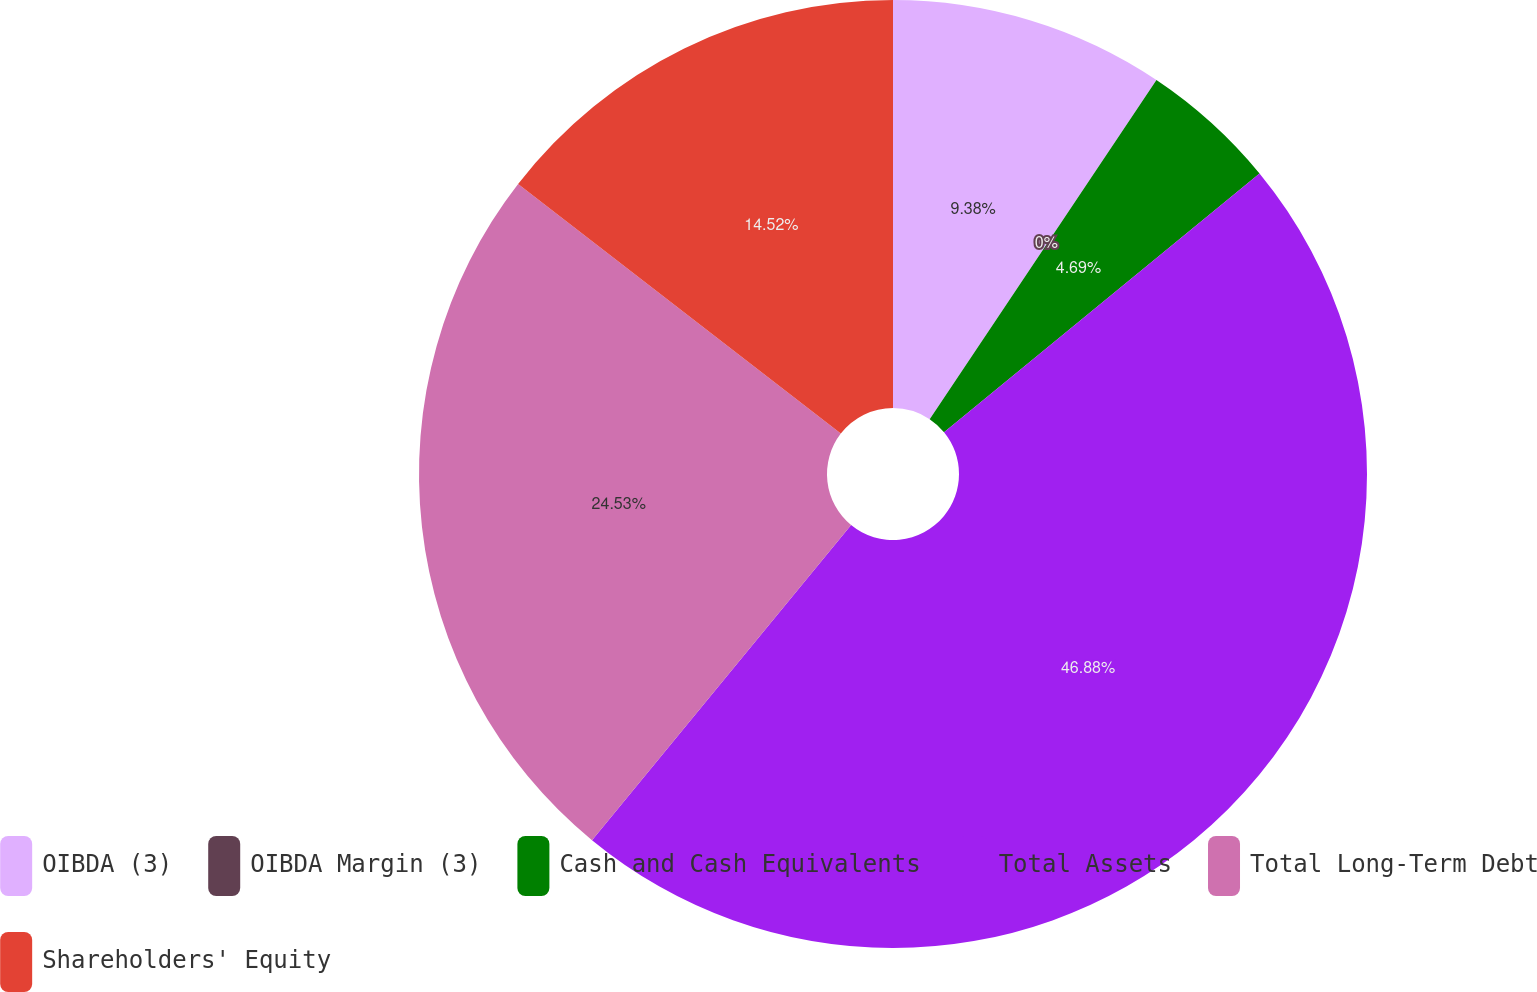<chart> <loc_0><loc_0><loc_500><loc_500><pie_chart><fcel>OIBDA (3)<fcel>OIBDA Margin (3)<fcel>Cash and Cash Equivalents<fcel>Total Assets<fcel>Total Long-Term Debt<fcel>Shareholders' Equity<nl><fcel>9.38%<fcel>0.0%<fcel>4.69%<fcel>46.88%<fcel>24.53%<fcel>14.52%<nl></chart> 